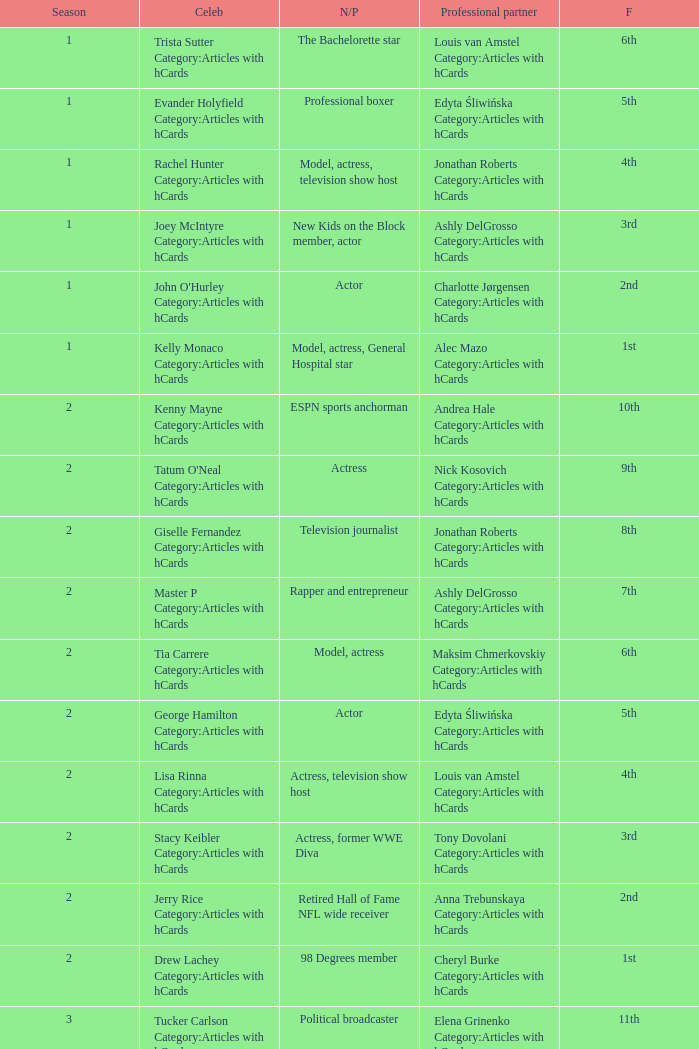What was the profession of the celebrity who was featured on season 15 and finished 7th place? Actress, comedian. 